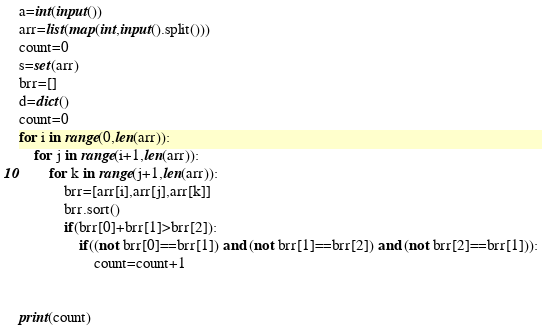Convert code to text. <code><loc_0><loc_0><loc_500><loc_500><_Python_>a=int(input())
arr=list(map(int,input().split()))
count=0
s=set(arr)
brr=[]
d=dict()
count=0
for i in range(0,len(arr)):
    for j in range(i+1,len(arr)):
        for k in range(j+1,len(arr)):
            brr=[arr[i],arr[j],arr[k]]
            brr.sort()
            if(brr[0]+brr[1]>brr[2]):
                if((not brr[0]==brr[1]) and (not brr[1]==brr[2]) and (not brr[2]==brr[1])):
                    count=count+1
                

print(count)</code> 